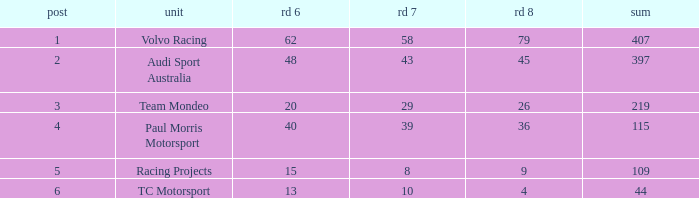What is the sum of total values for Rd 7 less than 8? None. 